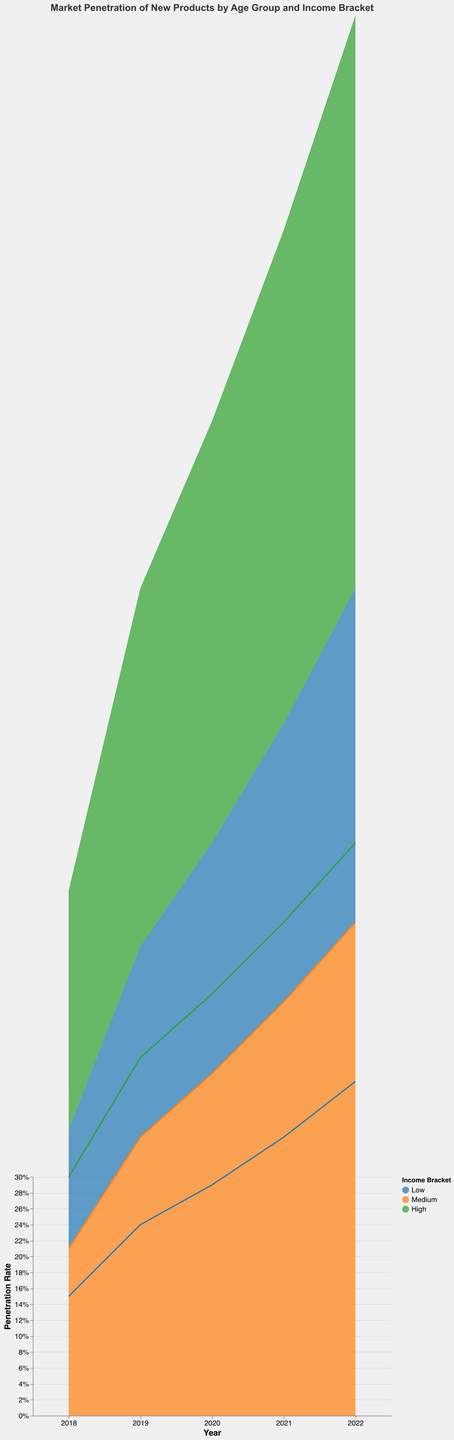What is the overall trend in market penetration rates across all products from 2018 to 2022? To identify the overall trend, look at the general direction of the lines and the area in the plot. The penetration rates for all income brackets seem to increase year-over-year across all age groups, indicating a positive upward trend.
Answer: Increasing Which age group consistently shows the highest penetration rates across the years? Examine the height of the areas and lines year by year, comparing the penetration rates across the age groups. The age group 18-25 consistently has the highest penetration rates.
Answer: 18-25 How does the market penetration of high-income consumers in 2022 compare to that in 2018? Look at the penetration rates for high-income consumers in both years. In 2022, the penetration rates for high-income consumers across all age groups are generally higher than those in 2018. For instance, in the 18-25 age group, it increased from 10% in 2018 to 24% in 2022.
Answer: Higher What is the penetration rate difference between medium and low-income brackets for the age group 26-35 in 2020? Locate the year 2020 on the x-axis and check the values for the medium and low-income brackets in the 26-35 age group. The medium-income bracket has a penetration rate of 16%, and the low-income bracket has 11%. The difference is 16% - 11% = 5%.
Answer: 5% Did any product experience a decrease in penetration rate from one year to the next? Analyze the changes in penetration rates for each product year-over-year across all segments. No product experienced a decrease in penetration rate from one year to the next, suggesting consistent growth across periods.
Answer: No Which income bracket sees the smallest fluctuation in penetration rates across the 5-year span? Observe the extent of change for each income bracket across the years. The low-income bracket shows the smallest fluctuation compared to medium and high-income brackets.
Answer: Low What year saw the highest overall market penetration for new product releases? Sum the penetration rates for all demographics for each year to find the maximum. The year 2022 saw the highest overall market penetration as it has the highest stack height across all segments.
Answer: 2022 Among the age group 36-50, which income bracket shows the highest penetration rate in 2021? Locate the age group 36-50 for the year 2021 and compare the penetration rates for different income brackets. The high-income bracket shows the highest rate at 19%.
Answer: High How much did the penetration rate increase for the medium-income bracket in the 18-25 age group from 2019 to 2022? Check the values for 2019 and 2022 for medium-income bracket in age group 18-25. In 2019, the penetration rate was 12%, and in 2022, it was 21%. The increase is 21% - 12% = 9%.
Answer: 9% In which year did the 26-35 age group with high income see the highest penetration rate? Look at the penetration rates over the years for the 26-35 age group with high income. The highest penetration rate was in 2022 at 26%.
Answer: 2022 